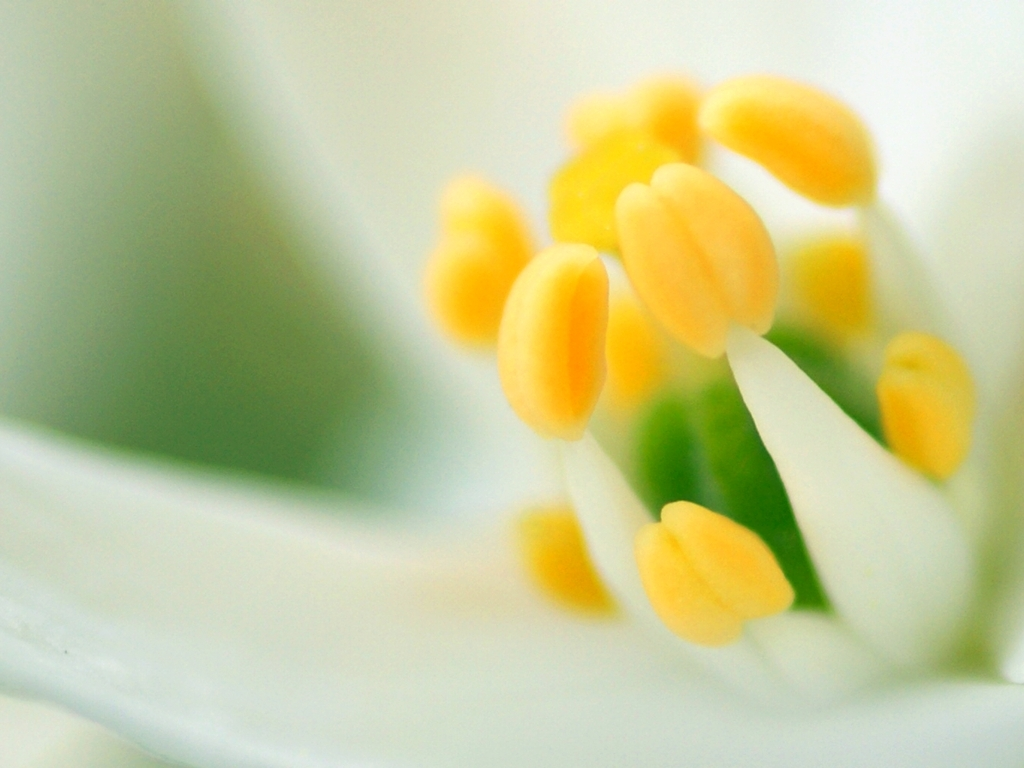What kind of flower is this? The close-up image of the flower center suggests it might be a lily, characterized by its prominent anthers on filament stalks. However, a full view of the petals and the plant would be required for a definitive identification. 